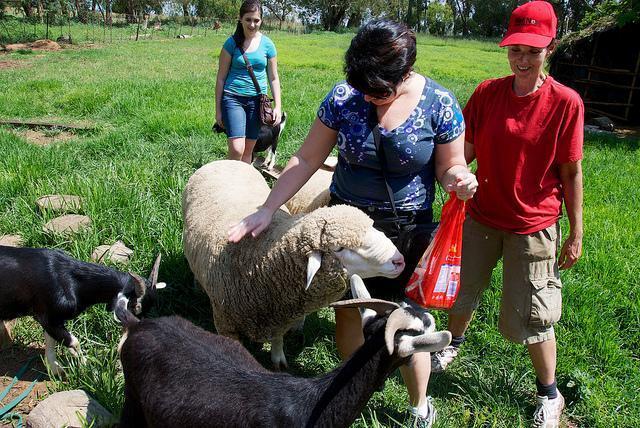How many people are in the photo?
Give a very brief answer. 3. How many sheep are there?
Give a very brief answer. 3. How many cows are eating?
Give a very brief answer. 0. 